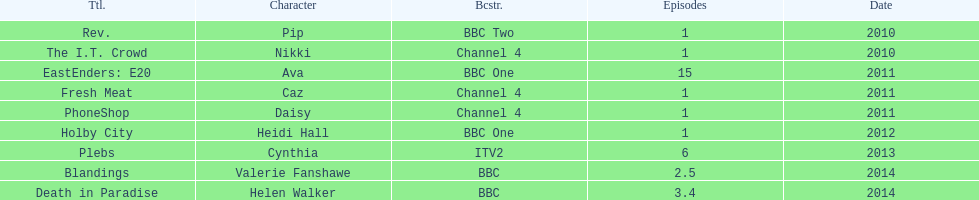Were there more than four episodes that featured cynthia? Yes. 